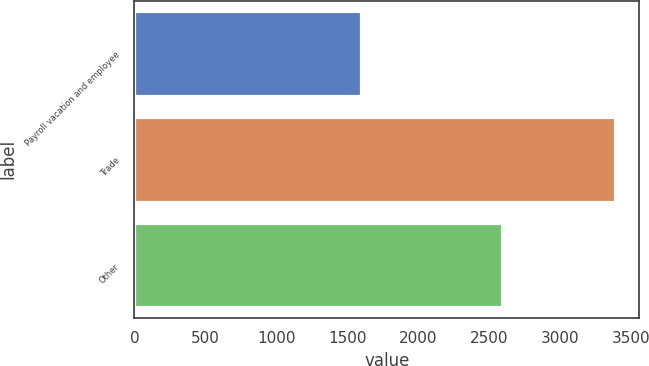Convert chart to OTSL. <chart><loc_0><loc_0><loc_500><loc_500><bar_chart><fcel>Payroll vacation and employee<fcel>Trade<fcel>Other<nl><fcel>1597<fcel>3389<fcel>2593<nl></chart> 